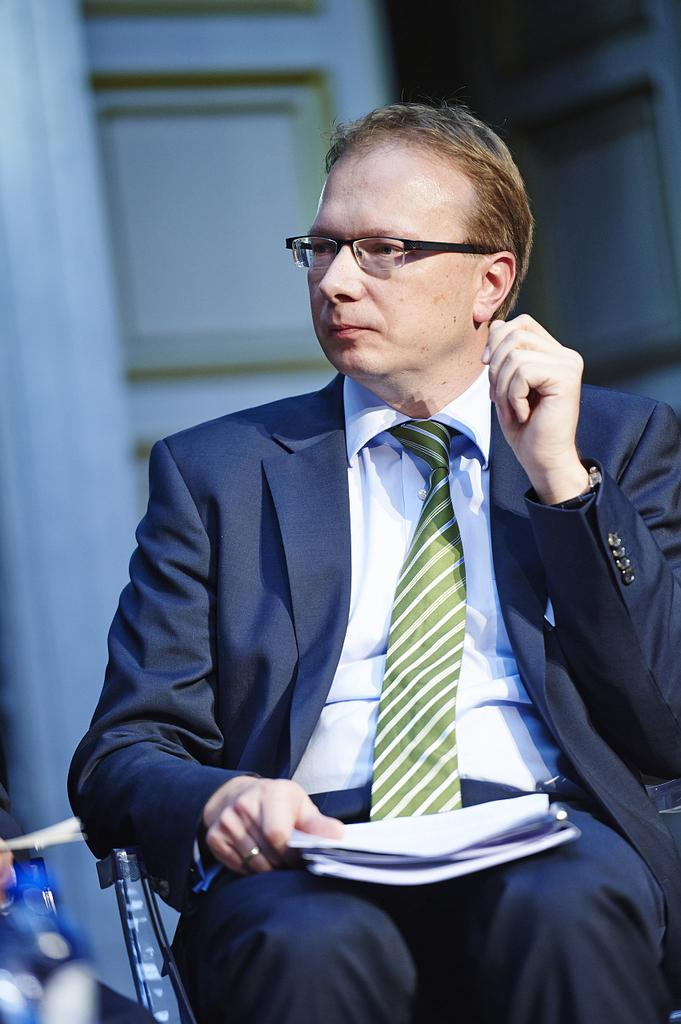What can be seen in the background of the image? There is a door in the background of the image. What is the man in the image doing? The man is sitting on a chair in the image. What accessories is the man wearing? The man is wearing spectacles, a shirt, a tie, and a blazer. What is the man holding in his hand? The man is holding papers in his hand. What type of corn is the man eating in the image? There is no corn present in the image; the man is holding papers in his hand. Is the man using a notebook to write down his thoughts in the image? There is no notebook visible in the image; the man is holding papers in his hand. 